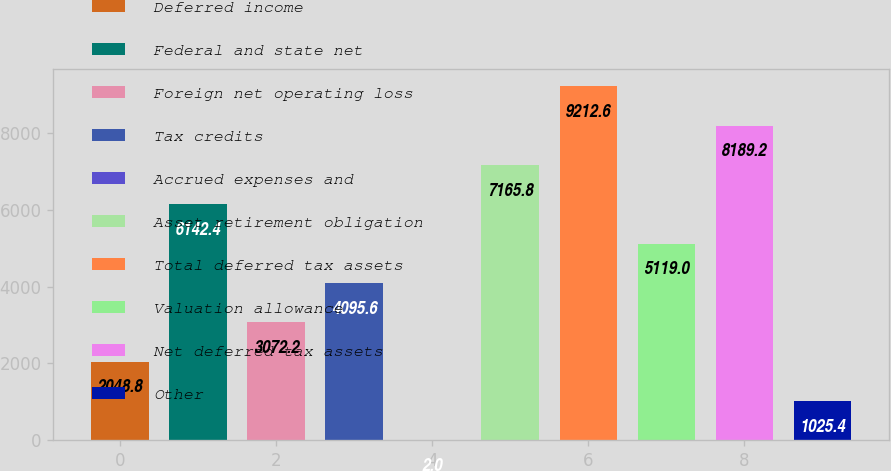<chart> <loc_0><loc_0><loc_500><loc_500><bar_chart><fcel>Deferred income<fcel>Federal and state net<fcel>Foreign net operating loss<fcel>Tax credits<fcel>Accrued expenses and<fcel>Asset retirement obligation<fcel>Total deferred tax assets<fcel>Valuation allowance<fcel>Net deferred tax assets<fcel>Other<nl><fcel>2048.8<fcel>6142.4<fcel>3072.2<fcel>4095.6<fcel>2<fcel>7165.8<fcel>9212.6<fcel>5119<fcel>8189.2<fcel>1025.4<nl></chart> 